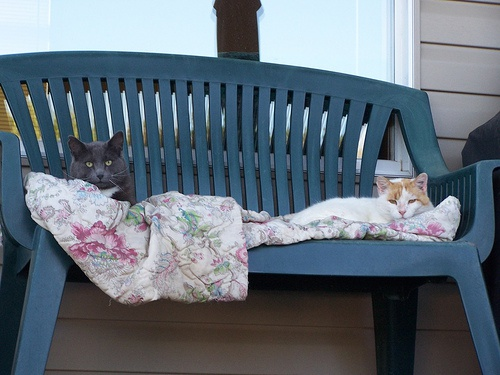Describe the objects in this image and their specific colors. I can see bench in white, blue, black, and gray tones, cat in white, lightgray, darkgray, and tan tones, and cat in white, black, gray, and blue tones in this image. 